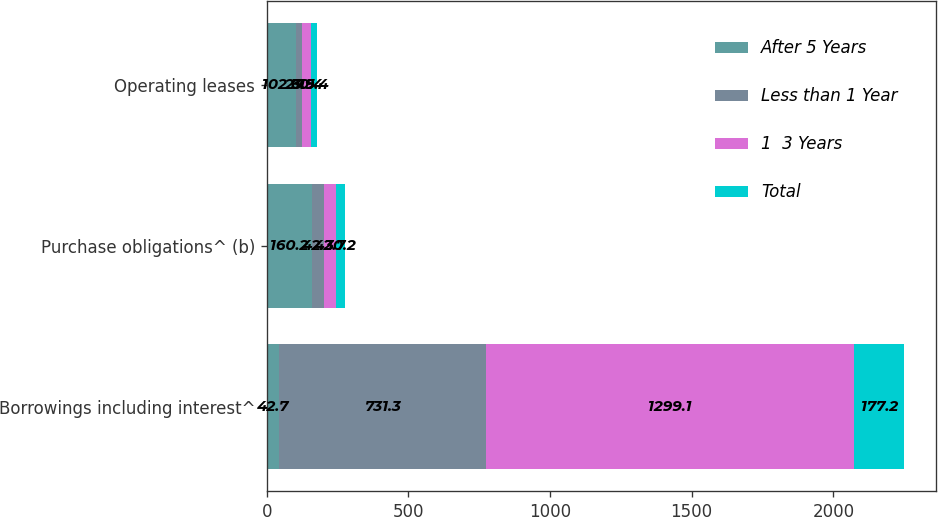<chart> <loc_0><loc_0><loc_500><loc_500><stacked_bar_chart><ecel><fcel>Borrowings including interest^<fcel>Purchase obligations^ (b)<fcel>Operating leases<nl><fcel>After 5 Years<fcel>42.7<fcel>160.2<fcel>102.6<nl><fcel>Less than 1 Year<fcel>731.3<fcel>42.3<fcel>23.5<nl><fcel>1  3 Years<fcel>1299.1<fcel>42.7<fcel>30.4<nl><fcel>Total<fcel>177.2<fcel>30.2<fcel>19.4<nl></chart> 